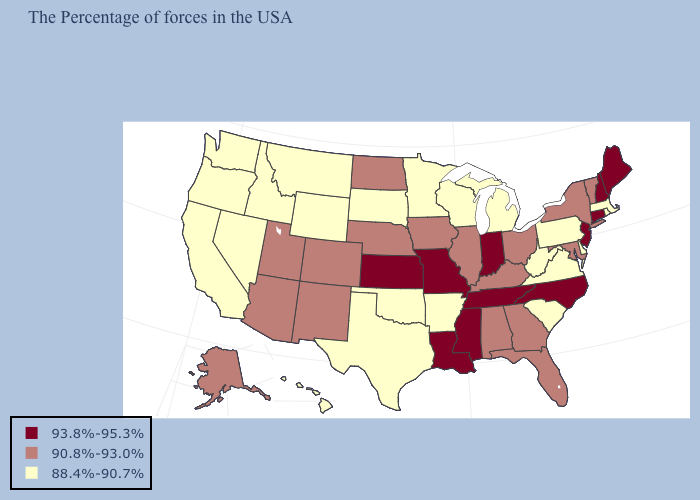Name the states that have a value in the range 93.8%-95.3%?
Give a very brief answer. Maine, New Hampshire, Connecticut, New Jersey, North Carolina, Indiana, Tennessee, Mississippi, Louisiana, Missouri, Kansas. What is the highest value in the USA?
Quick response, please. 93.8%-95.3%. Among the states that border Nebraska , which have the lowest value?
Concise answer only. South Dakota, Wyoming. What is the value of Connecticut?
Quick response, please. 93.8%-95.3%. Does Kansas have the same value as Missouri?
Short answer required. Yes. Does North Carolina have a higher value than New Hampshire?
Concise answer only. No. What is the value of Indiana?
Short answer required. 93.8%-95.3%. What is the lowest value in the Northeast?
Give a very brief answer. 88.4%-90.7%. Does West Virginia have the same value as New York?
Answer briefly. No. What is the lowest value in states that border Rhode Island?
Answer briefly. 88.4%-90.7%. What is the lowest value in the USA?
Quick response, please. 88.4%-90.7%. Which states have the highest value in the USA?
Quick response, please. Maine, New Hampshire, Connecticut, New Jersey, North Carolina, Indiana, Tennessee, Mississippi, Louisiana, Missouri, Kansas. How many symbols are there in the legend?
Short answer required. 3. Name the states that have a value in the range 93.8%-95.3%?
Keep it brief. Maine, New Hampshire, Connecticut, New Jersey, North Carolina, Indiana, Tennessee, Mississippi, Louisiana, Missouri, Kansas. Does Utah have the lowest value in the West?
Keep it brief. No. 